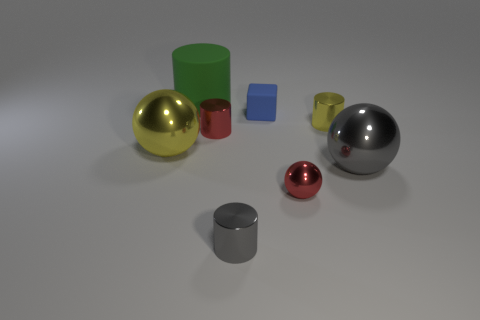Subtract all gray balls. How many balls are left? 2 Add 1 yellow cylinders. How many objects exist? 9 Subtract all gray spheres. How many spheres are left? 2 Subtract 1 cylinders. How many cylinders are left? 3 Subtract all green cylinders. Subtract all cyan cubes. How many cylinders are left? 3 Subtract all yellow cylinders. How many red spheres are left? 1 Subtract all big rubber cylinders. Subtract all small cyan metallic spheres. How many objects are left? 7 Add 8 small rubber blocks. How many small rubber blocks are left? 9 Add 1 tiny red shiny balls. How many tiny red shiny balls exist? 2 Subtract 0 purple cylinders. How many objects are left? 8 